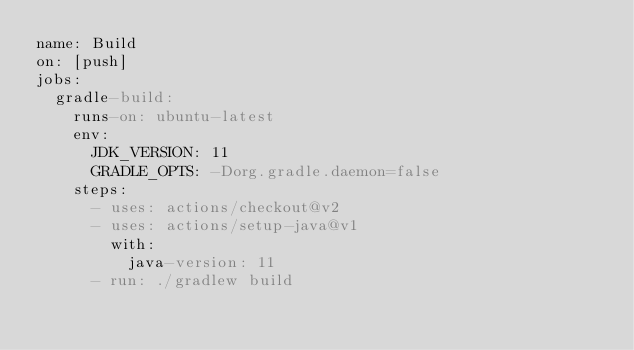Convert code to text. <code><loc_0><loc_0><loc_500><loc_500><_YAML_>name: Build
on: [push]
jobs:
  gradle-build:
    runs-on: ubuntu-latest
    env:
      JDK_VERSION: 11
      GRADLE_OPTS: -Dorg.gradle.daemon=false
    steps:
      - uses: actions/checkout@v2
      - uses: actions/setup-java@v1
        with:
          java-version: 11
      - run: ./gradlew build
</code> 